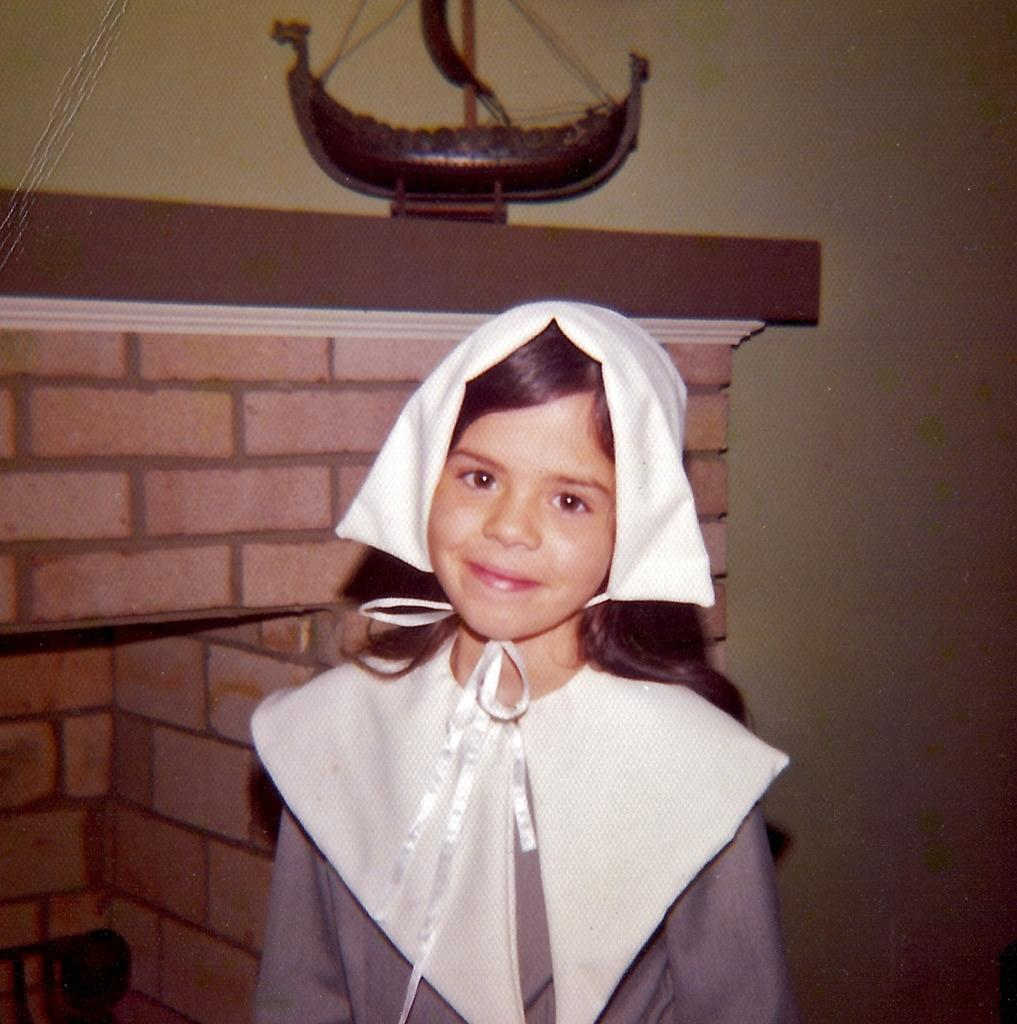Who is the main subject in the image? There is a girl in the image. What is the girl doing in the image? The girl is standing. What object can be seen at the top of the image? There is a toy boat at the top of the image. What type of magic is the girl performing with the toy boat in the image? There is no indication of magic or any magical activity in the image. The girl is simply standing, and the toy boat is at the top of the image. 